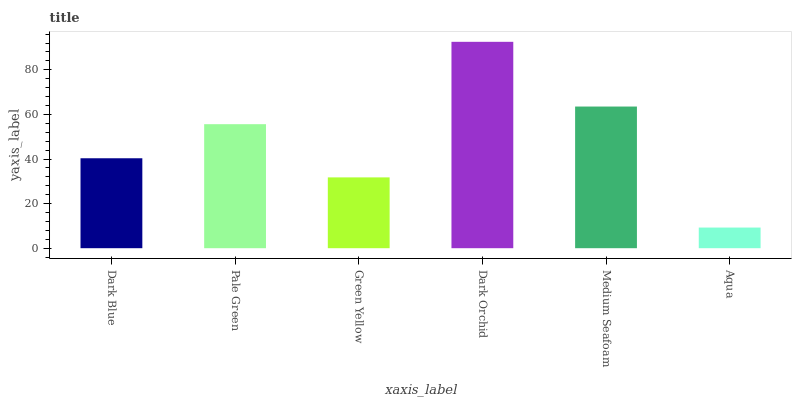Is Aqua the minimum?
Answer yes or no. Yes. Is Dark Orchid the maximum?
Answer yes or no. Yes. Is Pale Green the minimum?
Answer yes or no. No. Is Pale Green the maximum?
Answer yes or no. No. Is Pale Green greater than Dark Blue?
Answer yes or no. Yes. Is Dark Blue less than Pale Green?
Answer yes or no. Yes. Is Dark Blue greater than Pale Green?
Answer yes or no. No. Is Pale Green less than Dark Blue?
Answer yes or no. No. Is Pale Green the high median?
Answer yes or no. Yes. Is Dark Blue the low median?
Answer yes or no. Yes. Is Aqua the high median?
Answer yes or no. No. Is Aqua the low median?
Answer yes or no. No. 